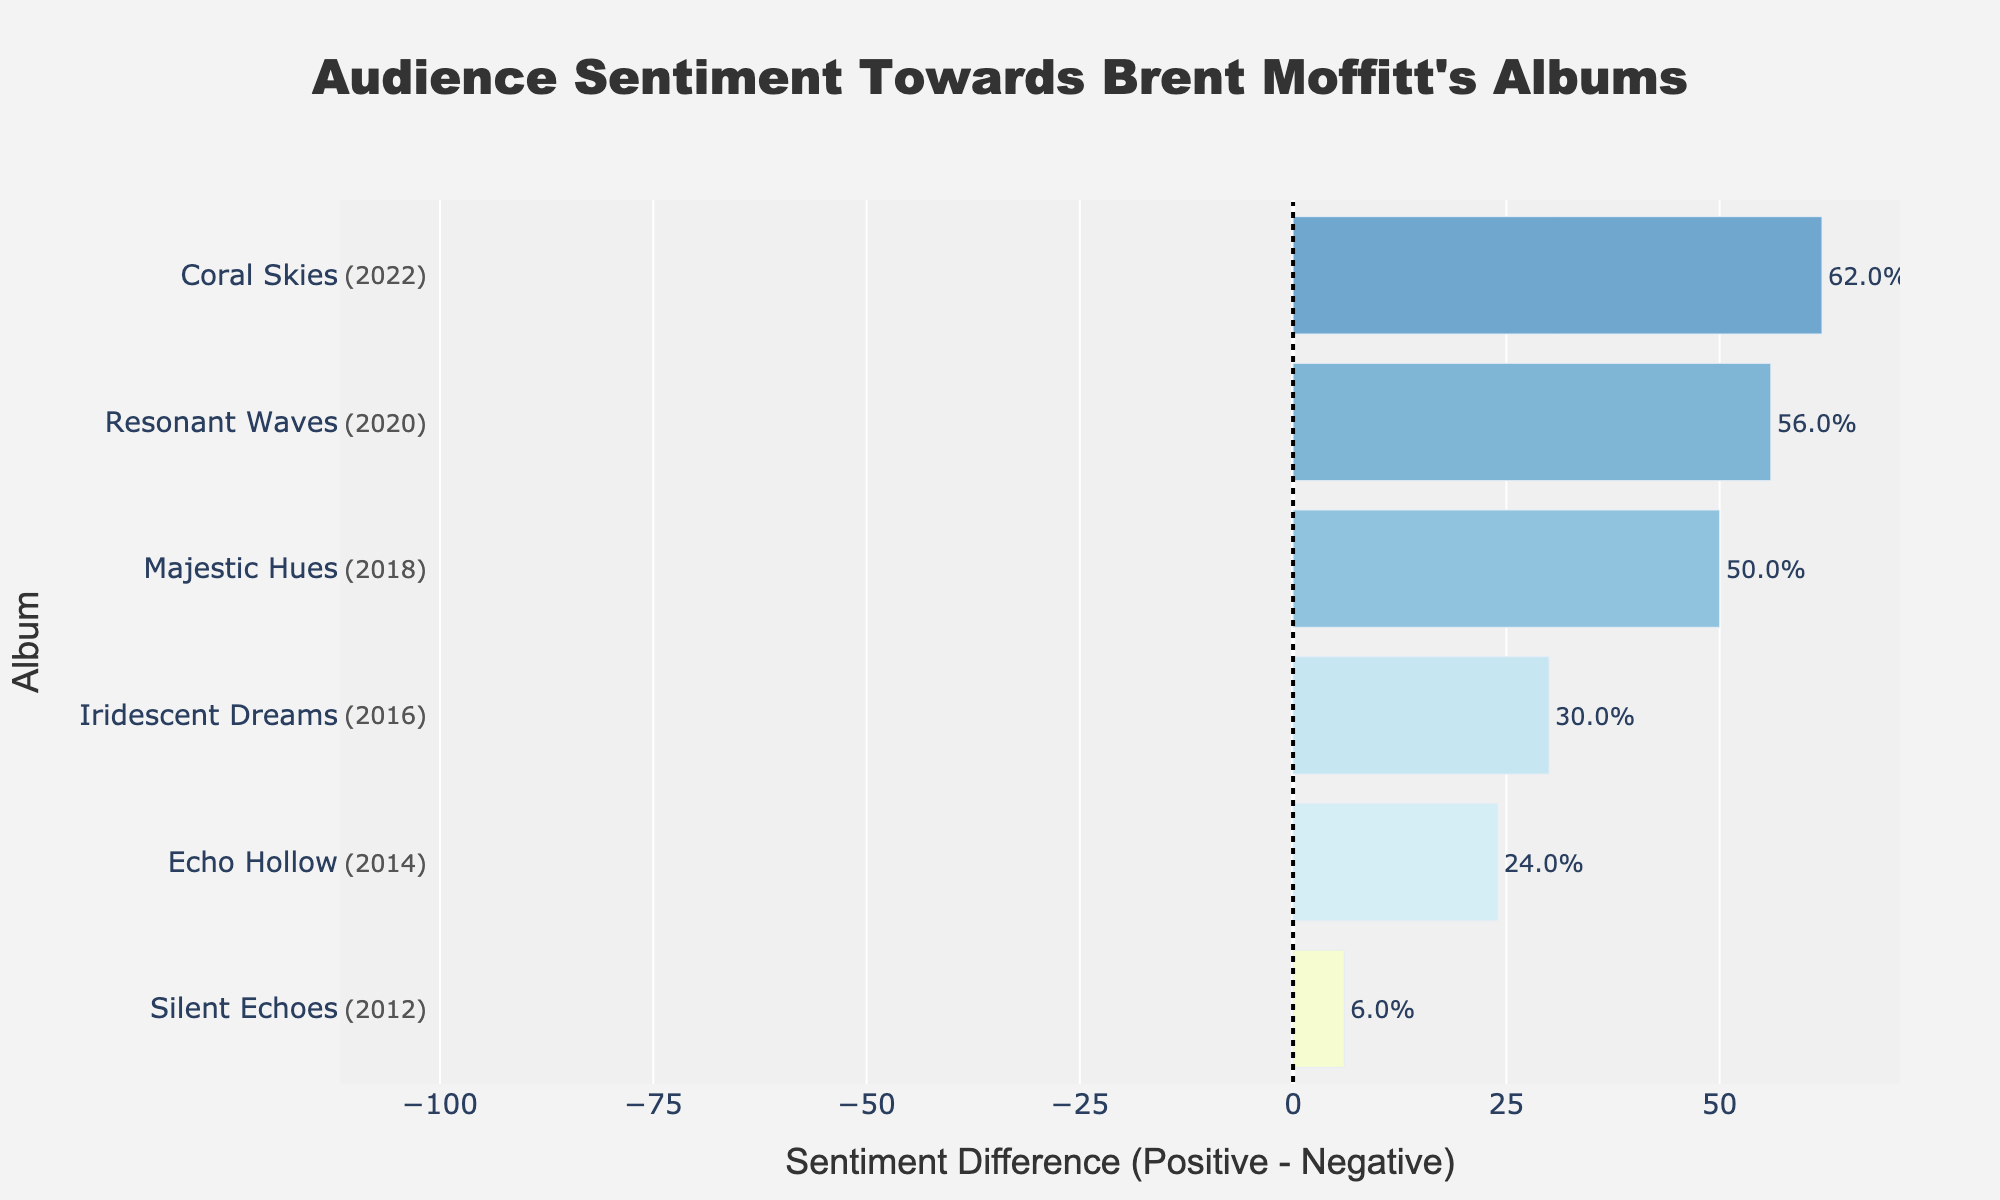What is the overall trend in positive sentiment towards Brent Moffitt's albums over time? The visual trend demonstrates a general upward trajectory in positive sentiment from "Silent Echoes" to "Coral Skies", before slightly declining in "Majestic Hues". This indicates that while there may be fluctuations, the positive sentiment generally increases over time.
Answer: Generally upward Which album had the highest positive sentiment percentage? The bar for "Coral Skies" is the longest in the positive direction indicating the highest percentage.
Answer: "Coral Skies" Which album had the lowest negative sentiment percentage? The bar for "Coral Skies" is the least extended in the negative direction, meaning it has the lowest negative sentiment percentage.
Answer: "Coral Skies" What is the sentiment difference for "Resonant Waves"? The difference is calculated from the positive sentiment percentage (78%) and the negative sentiment percentage (22%). 78% - 22% equals to 56%.
Answer: 56% Between "Iridescent Dreams" and "Echo Hollow", which album has a higher sentiment difference? The bar for "Iridescent Dreams" extends further in the positive direction than "Echo Hollow", indicating a higher sentiment difference for "Iridescent Dreams".
Answer: "Iridescent Dreams" On which album does the positive sentiment exceed the negative sentiment by more than 50%? The only bar that extends more than 50% in the positive direction is "Coral Skies" at 62%.
Answer: "Coral Skies" What is the average positive sentiment percentage across all albums? Summing up the positive sentiment percentages (65 + 53 + 78 + 62 + 81 + 75) gives 414%. Dividing by the number of albums (6), the average is 414/6 = 69%.
Answer: 69% Which albums have a positive sentiment percentage greater than 70%? From the figure, "Coral Skies" and "Resonant Waves" have bars extending beyond the 70% mark towards the positive side.
Answer: "Coral Skies" and "Resonant Waves" How does the sentiment of "Silent Echoes" compare with the sentiment of "Majestic Hues"? "Silent Echoes" has a lower positive sentiment (53%) than "Majestic Hues" (75%) and a higher negative sentiment (47%) compared to "Majestic Hues" (25%).
Answer: "Majestic Hues" has better sentiment Which album shows the largest deviation from an equal sentiment distribution (50% positive and 50% negative)? "Coral Skies" shows the largest deviation as it has the highest positive sentiment and lowest negative sentiment.
Answer: "Coral Skies" 